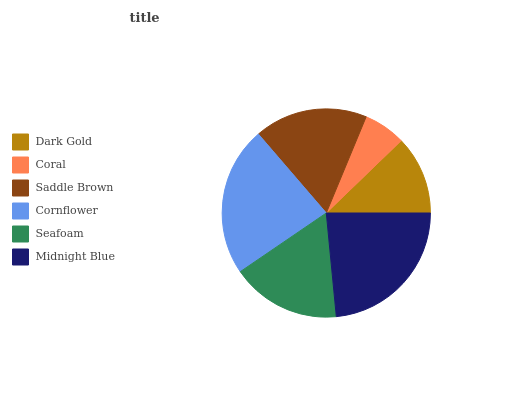Is Coral the minimum?
Answer yes or no. Yes. Is Midnight Blue the maximum?
Answer yes or no. Yes. Is Saddle Brown the minimum?
Answer yes or no. No. Is Saddle Brown the maximum?
Answer yes or no. No. Is Saddle Brown greater than Coral?
Answer yes or no. Yes. Is Coral less than Saddle Brown?
Answer yes or no. Yes. Is Coral greater than Saddle Brown?
Answer yes or no. No. Is Saddle Brown less than Coral?
Answer yes or no. No. Is Saddle Brown the high median?
Answer yes or no. Yes. Is Seafoam the low median?
Answer yes or no. Yes. Is Seafoam the high median?
Answer yes or no. No. Is Coral the low median?
Answer yes or no. No. 